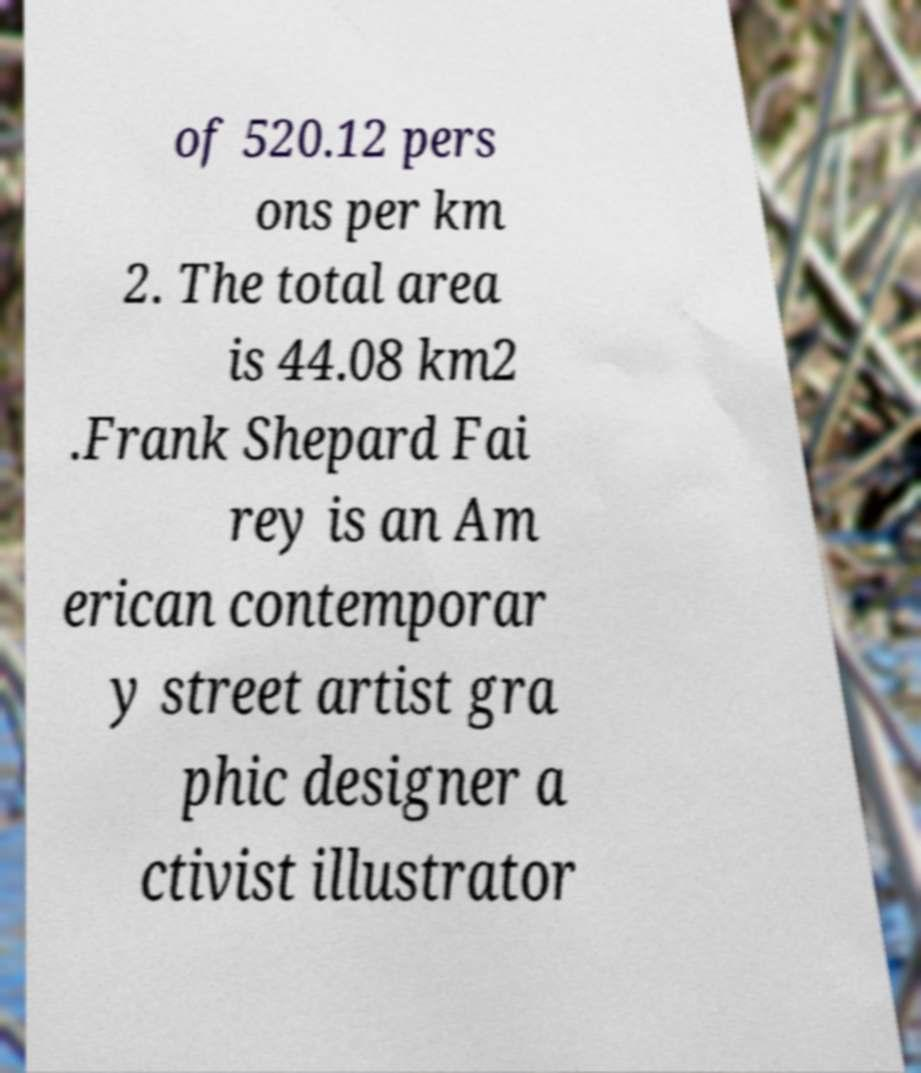Please read and relay the text visible in this image. What does it say? of 520.12 pers ons per km 2. The total area is 44.08 km2 .Frank Shepard Fai rey is an Am erican contemporar y street artist gra phic designer a ctivist illustrator 